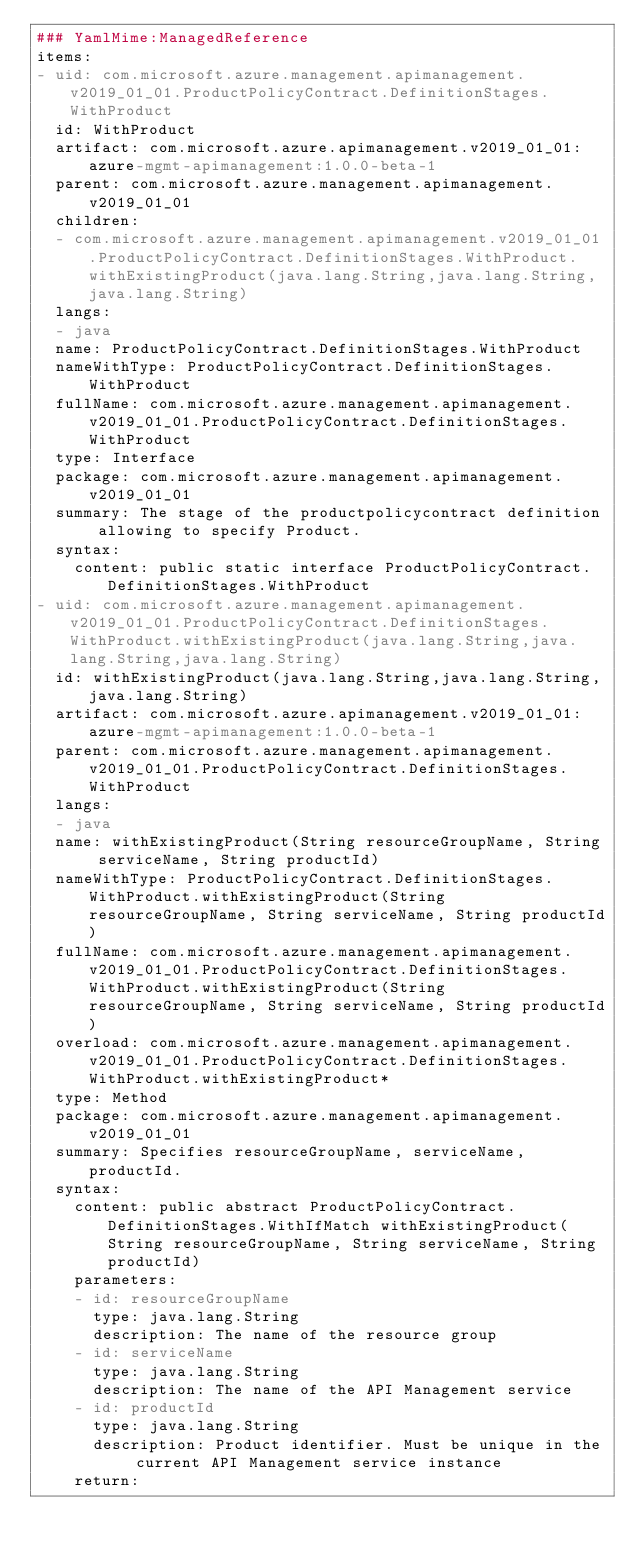Convert code to text. <code><loc_0><loc_0><loc_500><loc_500><_YAML_>### YamlMime:ManagedReference
items:
- uid: com.microsoft.azure.management.apimanagement.v2019_01_01.ProductPolicyContract.DefinitionStages.WithProduct
  id: WithProduct
  artifact: com.microsoft.azure.apimanagement.v2019_01_01:azure-mgmt-apimanagement:1.0.0-beta-1
  parent: com.microsoft.azure.management.apimanagement.v2019_01_01
  children:
  - com.microsoft.azure.management.apimanagement.v2019_01_01.ProductPolicyContract.DefinitionStages.WithProduct.withExistingProduct(java.lang.String,java.lang.String,java.lang.String)
  langs:
  - java
  name: ProductPolicyContract.DefinitionStages.WithProduct
  nameWithType: ProductPolicyContract.DefinitionStages.WithProduct
  fullName: com.microsoft.azure.management.apimanagement.v2019_01_01.ProductPolicyContract.DefinitionStages.WithProduct
  type: Interface
  package: com.microsoft.azure.management.apimanagement.v2019_01_01
  summary: The stage of the productpolicycontract definition allowing to specify Product.
  syntax:
    content: public static interface ProductPolicyContract.DefinitionStages.WithProduct
- uid: com.microsoft.azure.management.apimanagement.v2019_01_01.ProductPolicyContract.DefinitionStages.WithProduct.withExistingProduct(java.lang.String,java.lang.String,java.lang.String)
  id: withExistingProduct(java.lang.String,java.lang.String,java.lang.String)
  artifact: com.microsoft.azure.apimanagement.v2019_01_01:azure-mgmt-apimanagement:1.0.0-beta-1
  parent: com.microsoft.azure.management.apimanagement.v2019_01_01.ProductPolicyContract.DefinitionStages.WithProduct
  langs:
  - java
  name: withExistingProduct(String resourceGroupName, String serviceName, String productId)
  nameWithType: ProductPolicyContract.DefinitionStages.WithProduct.withExistingProduct(String resourceGroupName, String serviceName, String productId)
  fullName: com.microsoft.azure.management.apimanagement.v2019_01_01.ProductPolicyContract.DefinitionStages.WithProduct.withExistingProduct(String resourceGroupName, String serviceName, String productId)
  overload: com.microsoft.azure.management.apimanagement.v2019_01_01.ProductPolicyContract.DefinitionStages.WithProduct.withExistingProduct*
  type: Method
  package: com.microsoft.azure.management.apimanagement.v2019_01_01
  summary: Specifies resourceGroupName, serviceName, productId.
  syntax:
    content: public abstract ProductPolicyContract.DefinitionStages.WithIfMatch withExistingProduct(String resourceGroupName, String serviceName, String productId)
    parameters:
    - id: resourceGroupName
      type: java.lang.String
      description: The name of the resource group
    - id: serviceName
      type: java.lang.String
      description: The name of the API Management service
    - id: productId
      type: java.lang.String
      description: Product identifier. Must be unique in the current API Management service instance
    return:</code> 